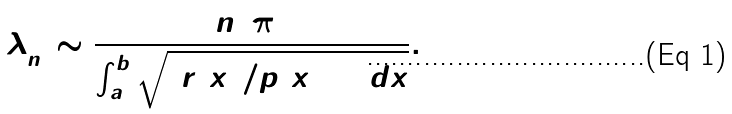<formula> <loc_0><loc_0><loc_500><loc_500>\lambda _ { n } ^ { + } \sim \frac { n ^ { 2 } \, \pi ^ { 2 } } { \int _ { a } ^ { b } \sqrt { \left ( { r ( x ) } / { p ( x ) } \right ) _ { + } \, d x } } .</formula> 